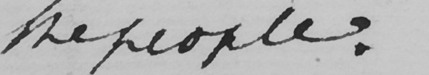What is written in this line of handwriting? the people : 